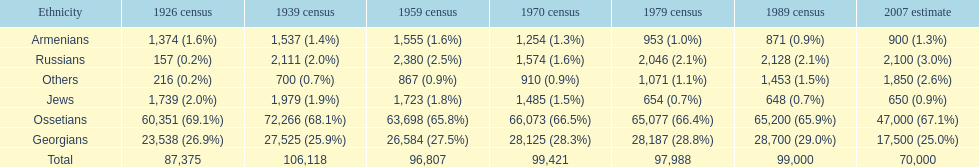Which population had the most people in 1926? Ossetians. 